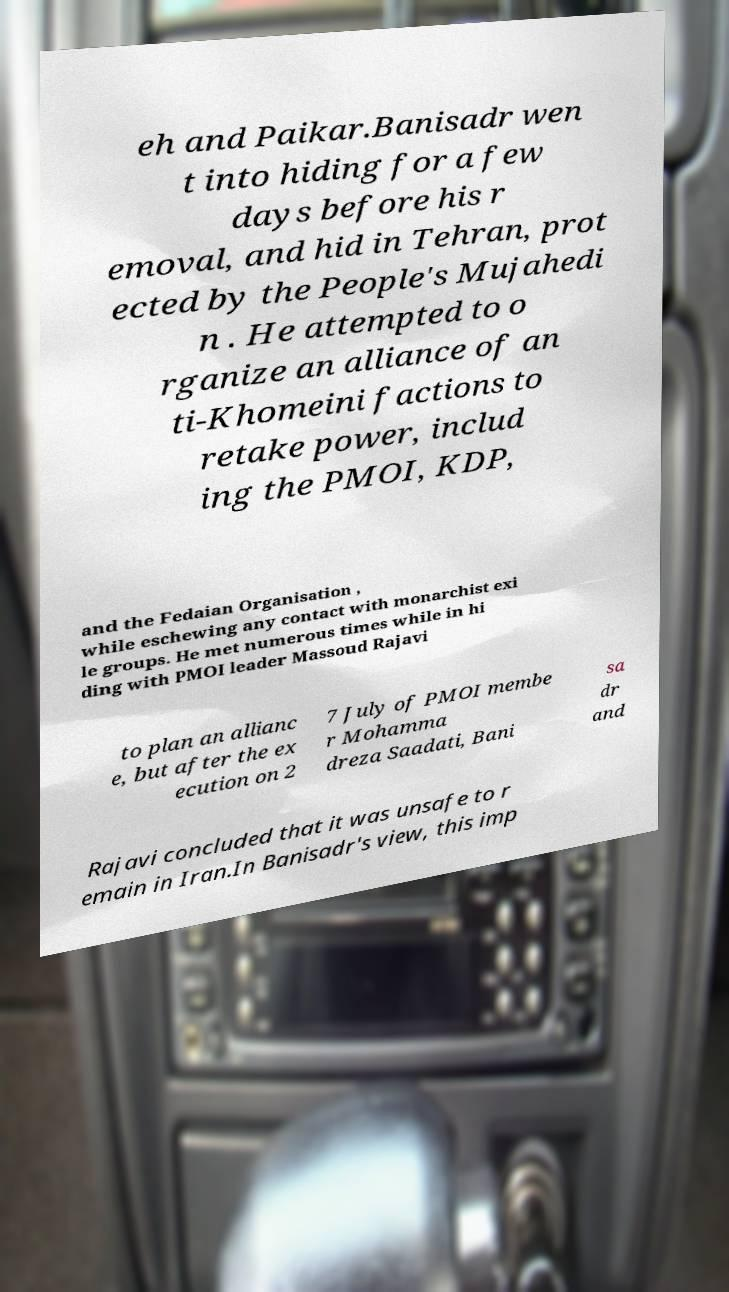Please read and relay the text visible in this image. What does it say? eh and Paikar.Banisadr wen t into hiding for a few days before his r emoval, and hid in Tehran, prot ected by the People's Mujahedi n . He attempted to o rganize an alliance of an ti-Khomeini factions to retake power, includ ing the PMOI, KDP, and the Fedaian Organisation , while eschewing any contact with monarchist exi le groups. He met numerous times while in hi ding with PMOI leader Massoud Rajavi to plan an allianc e, but after the ex ecution on 2 7 July of PMOI membe r Mohamma dreza Saadati, Bani sa dr and Rajavi concluded that it was unsafe to r emain in Iran.In Banisadr's view, this imp 